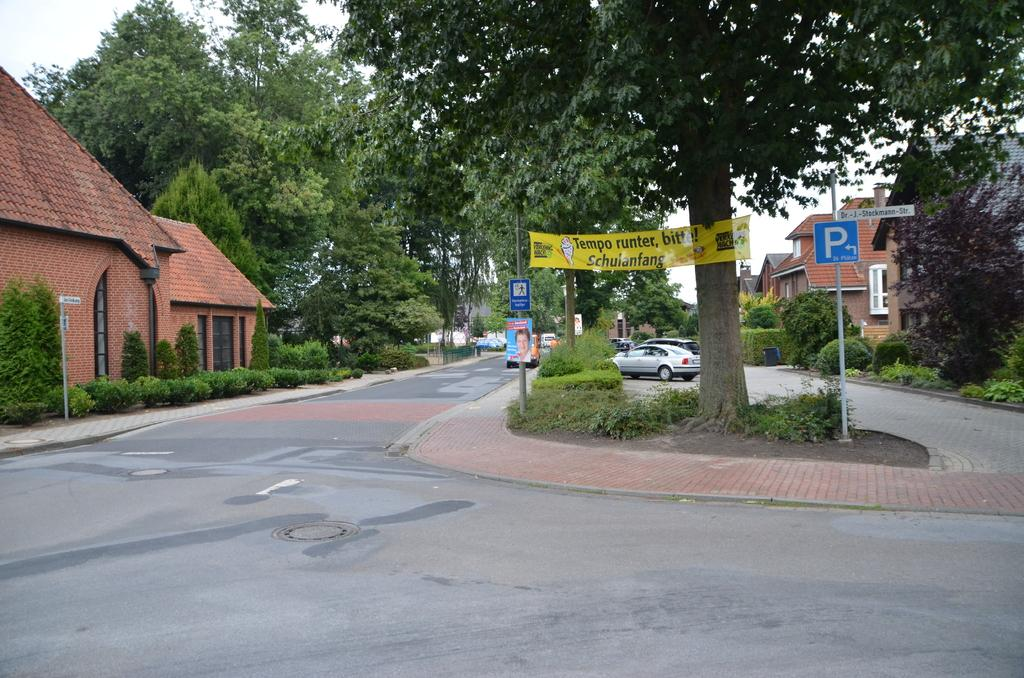What is hanging or displayed in the image? There is a banner in the image. What structures can be seen in the image? There are boards attached to poles, vehicles, buildings, plants, and trees in the image. What can be seen in the background of the image? The sky is visible in the background of the image. What type of juice is being served at the event depicted in the image? There is no juice or event depicted in the image; it only shows a banner, boards, vehicles, buildings, plants, trees, and the sky. Can you tell me who the father is in the image? There is no person or father present in the image; it only shows inanimate objects and the sky. 